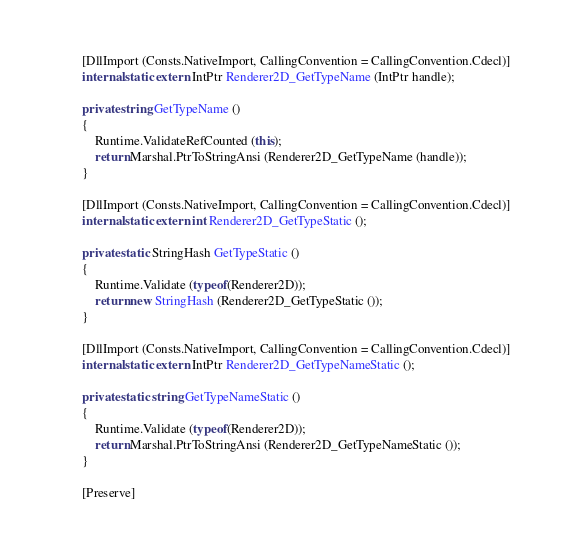Convert code to text. <code><loc_0><loc_0><loc_500><loc_500><_C#_>		[DllImport (Consts.NativeImport, CallingConvention = CallingConvention.Cdecl)]
		internal static extern IntPtr Renderer2D_GetTypeName (IntPtr handle);

		private string GetTypeName ()
		{
			Runtime.ValidateRefCounted (this);
			return Marshal.PtrToStringAnsi (Renderer2D_GetTypeName (handle));
		}

		[DllImport (Consts.NativeImport, CallingConvention = CallingConvention.Cdecl)]
		internal static extern int Renderer2D_GetTypeStatic ();

		private static StringHash GetTypeStatic ()
		{
			Runtime.Validate (typeof(Renderer2D));
			return new StringHash (Renderer2D_GetTypeStatic ());
		}

		[DllImport (Consts.NativeImport, CallingConvention = CallingConvention.Cdecl)]
		internal static extern IntPtr Renderer2D_GetTypeNameStatic ();

		private static string GetTypeNameStatic ()
		{
			Runtime.Validate (typeof(Renderer2D));
			return Marshal.PtrToStringAnsi (Renderer2D_GetTypeNameStatic ());
		}

		[Preserve]</code> 